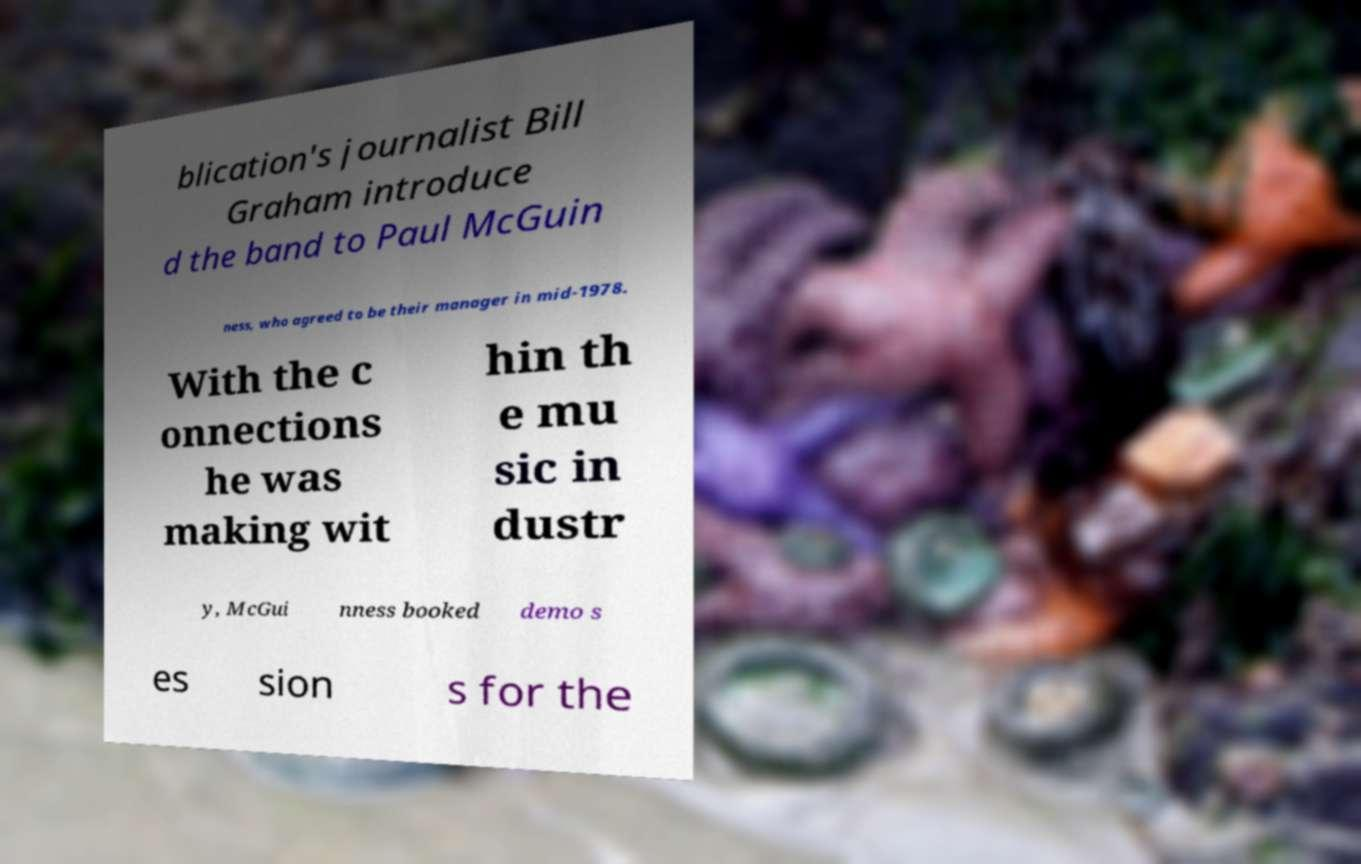Could you extract and type out the text from this image? blication's journalist Bill Graham introduce d the band to Paul McGuin ness, who agreed to be their manager in mid-1978. With the c onnections he was making wit hin th e mu sic in dustr y, McGui nness booked demo s es sion s for the 